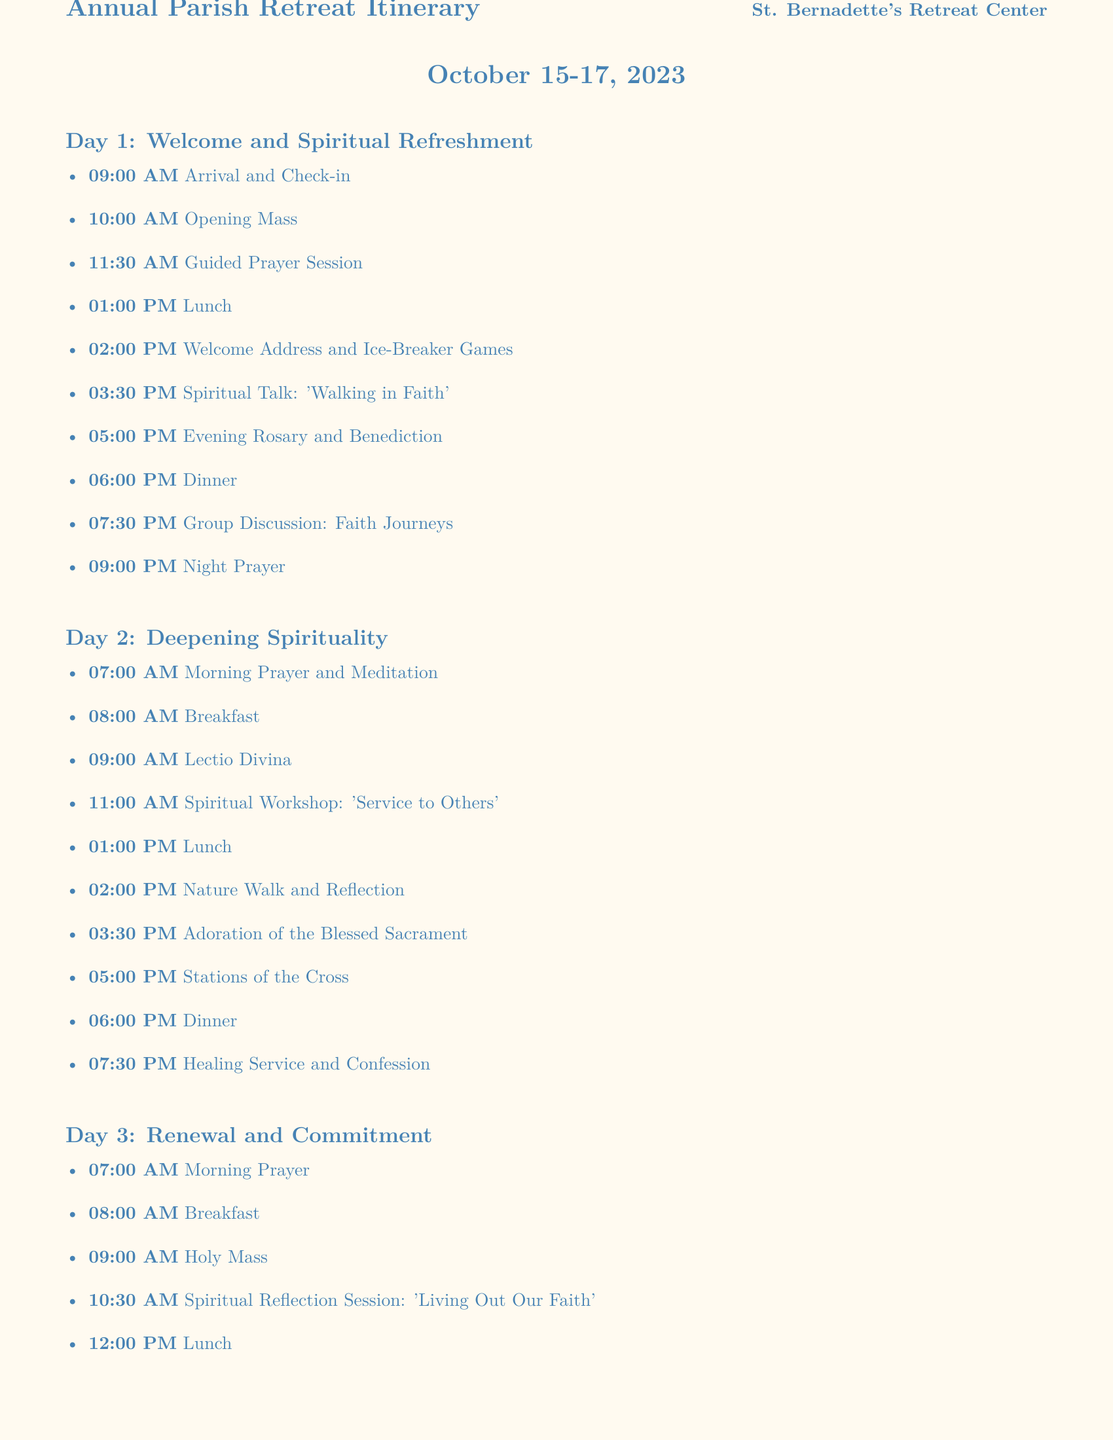What is the starting date of the retreat? The starting date of the retreat is explicitly stated at the top of the document.
Answer: October 15, 2023 What activity begins on Day 1 at 10:00 AM? The document lists the activities with their corresponding times, allowing for easy retrieval of scheduled events.
Answer: Opening Mass How many total days does the retreat last? The duration of the retreat can be determined from the dates provided in the document.
Answer: 3 days What is the theme of the spiritual talk on Day 1? The specific topic of the spiritual talk can be found in the itemized list of activities for Day 1.
Answer: Walking in Faith When does the Commitment Ceremony take place? The time for the Commitment Ceremony is specified in the itinerary, as it is a key highlight in the schedule.
Answer: 01:00 PM How long is the free time on Day 3? The schedule indicates the start and end time of free time, enabling the calculation of its duration.
Answer: 1 hour 30 minutes What should participants bring to the retreat? The additional notes section outlines what participants should bring for the retreat.
Answer: Bible, journal, comfortable clothing What is the last scheduled activity of the retreat? The document provides a clear sequence of activities ending with the final scheduled event, which is important for understanding the closure of the retreat.
Answer: Closing Prayer and Farewell 